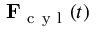<formula> <loc_0><loc_0><loc_500><loc_500>F _ { c y l } ( t )</formula> 